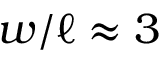Convert formula to latex. <formula><loc_0><loc_0><loc_500><loc_500>w / \ell \approx 3</formula> 